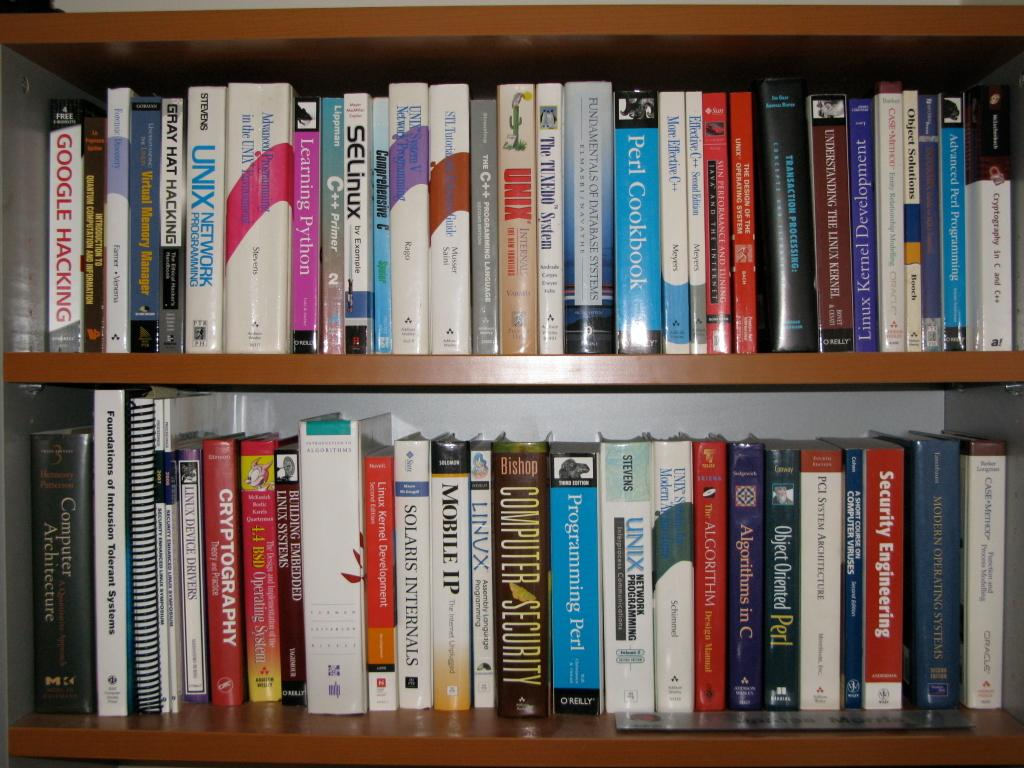What objects are visible in the image? There are books in the image. Where are the books located? The books are in shelves. Can you describe the position of the shelves in the image? The shelves are in the center of the image. How much sugar is present in the books in the image? There is no sugar present in the books in the image, as books are made of paper and contain written content. 